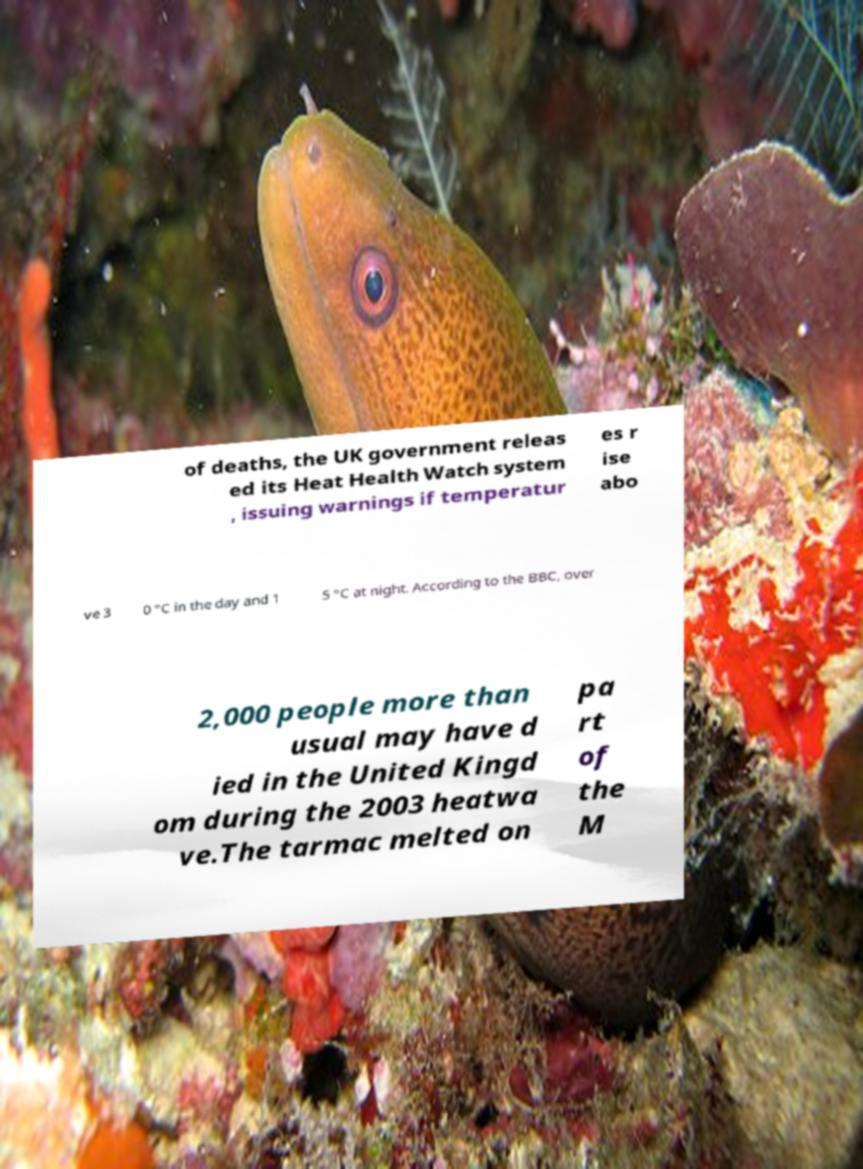What messages or text are displayed in this image? I need them in a readable, typed format. of deaths, the UK government releas ed its Heat Health Watch system , issuing warnings if temperatur es r ise abo ve 3 0 °C in the day and 1 5 °C at night. According to the BBC, over 2,000 people more than usual may have d ied in the United Kingd om during the 2003 heatwa ve.The tarmac melted on pa rt of the M 